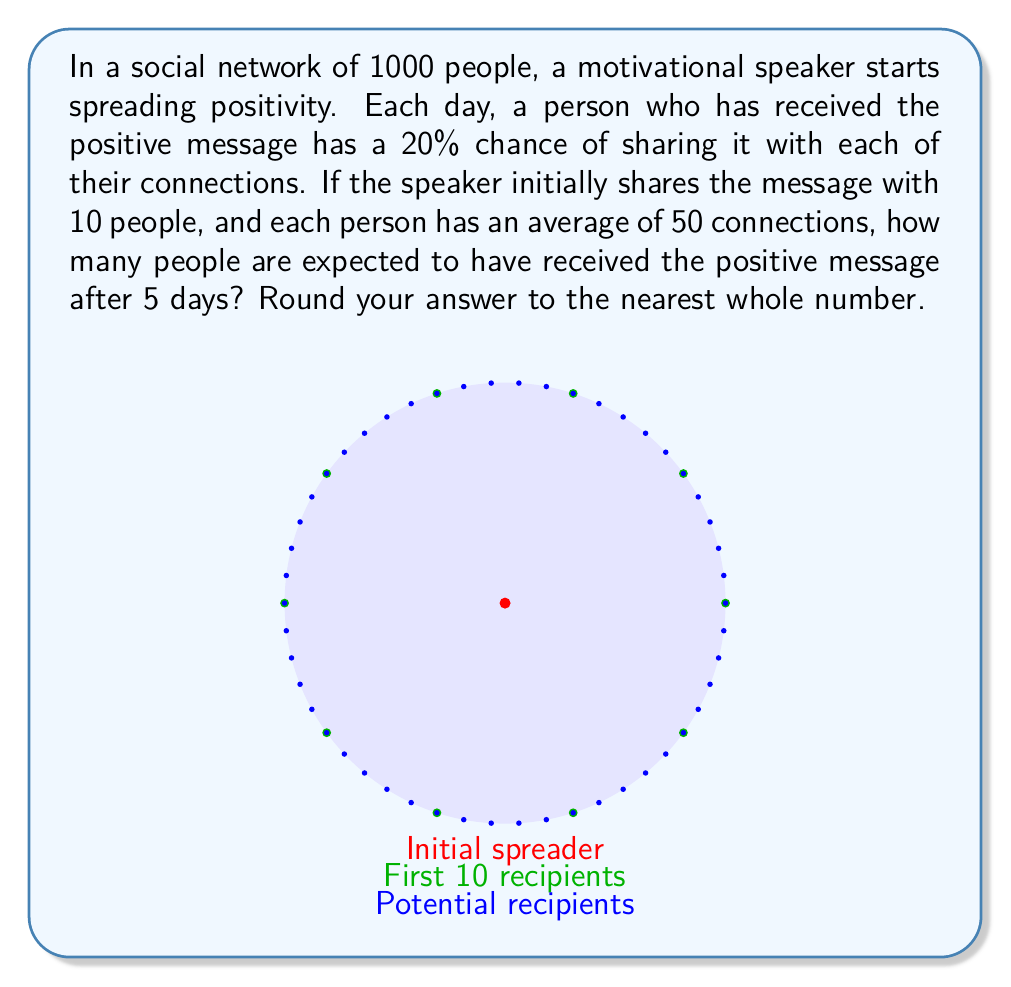Solve this math problem. Let's approach this step-by-step:

1) First, we need to calculate the probability of a message being spread from one person to another in a day:
   $p = 1 - (1 - 0.2)^{50} = 1 - 0.8^{50} \approx 0.9999$

2) Now, let's define $x_n$ as the number of people who have received the message after n days. We start with $x_0 = 10$.

3) For each subsequent day, we can calculate:
   $x_{n+1} = x_n + (1000 - x_n) \cdot (1 - (1-p)^{x_n})$

4) Let's calculate for each day:
   Day 1: $x_1 = 10 + (1000 - 10) \cdot (1 - (1-0.9999)^{10}) \approx 999.9$
   Day 2: $x_2 \approx 1000$
   Days 3-5: $x_3 = x_4 = x_5 \approx 1000$

5) The rapid spread is due to the high connectivity and high probability of sharing. In reality, network effects might slow this down, but given our simplified model, the message spreads to almost everyone by day 2.

Therefore, after 5 days, we expect approximately 1000 people to have received the positive message.
Answer: 1000 